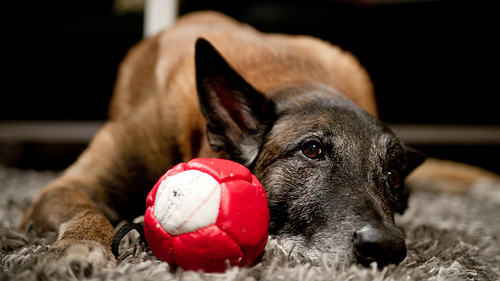<image>
Is there a ball in front of the dog? Yes. The ball is positioned in front of the dog, appearing closer to the camera viewpoint. 